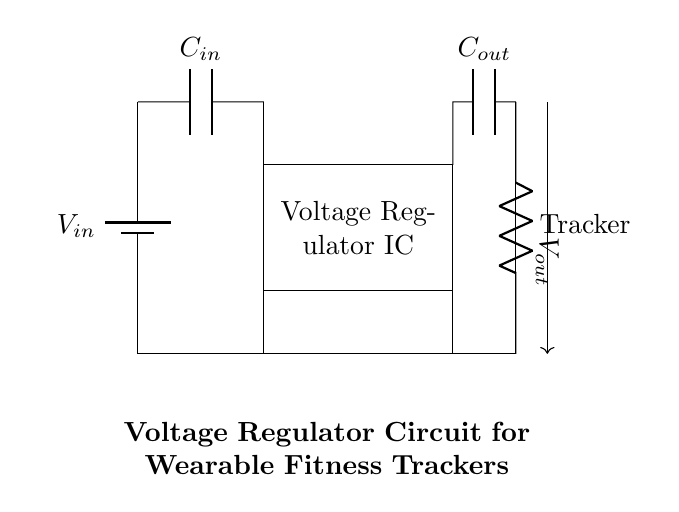What is the input voltage of this circuit? The input voltage, labeled as V_in, is represented at the left side of the circuit diagram, specifically by the battery component.
Answer: V_in What type of component is used as the voltage regulator? The voltage regulator is represented by a rectangular shape in the circuit, labeled as Voltage Regulator IC, which identifies it as an integrated circuit that regulates voltage.
Answer: Voltage Regulator IC How many capacitors are present in the circuit? The circuit diagram shows two capacitors: the input capacitor (C_in) and the output capacitor (C_out), which are indicated by the letters C followed by subscript in and out, respectively.
Answer: 2 What is the function of the load resistor? The load resistor, labeled as Tracker, represents the wearable fitness tracker, indicating that it is the device powered by the regulated voltage output.
Answer: Tracker What is the output voltage of the circuit? V_out is represented on the right side of the circuit diagram, indicating the voltage supplied to the load resistor, which would be a stable output value ensured by the voltage regulator.
Answer: V_out How do C_in and C_out affect the circuit? C_in filters out voltage spikes at the input side and stabilizes the input to the voltage regulator, while C_out smooths the output voltage to provide stable power to the load, reducing noise and fluctuations.
Answer: Stabilization Which component provides the ground reference for the circuit? The ground connections are shown at the bottom of the circuit diagram where multiple lines connect to indicate they are all tied to ground potentials, providing a common reference point.
Answer: Ground 